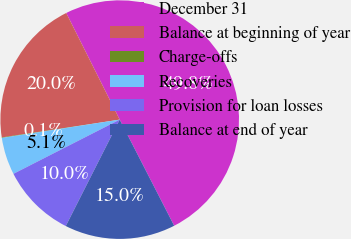<chart> <loc_0><loc_0><loc_500><loc_500><pie_chart><fcel>December 31<fcel>Balance at beginning of year<fcel>Charge-offs<fcel>Recoveries<fcel>Provision for loan losses<fcel>Balance at end of year<nl><fcel>49.85%<fcel>19.99%<fcel>0.07%<fcel>5.05%<fcel>10.03%<fcel>15.01%<nl></chart> 